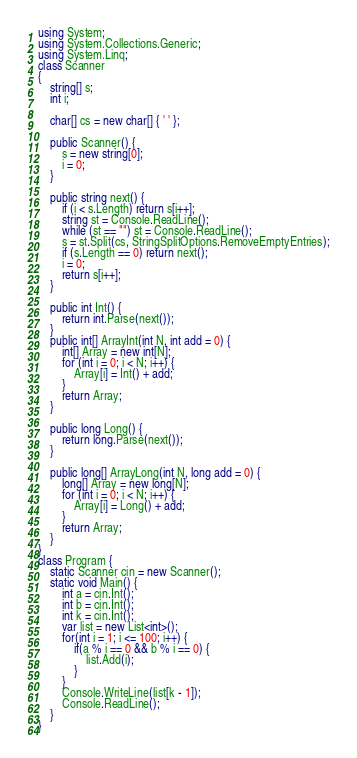<code> <loc_0><loc_0><loc_500><loc_500><_C#_>using System;
using System.Collections.Generic;
using System.Linq;
class Scanner
{
    string[] s;
    int i;

    char[] cs = new char[] { ' ' };

    public Scanner() {
        s = new string[0];
        i = 0;
    }

    public string next() {
        if (i < s.Length) return s[i++];
        string st = Console.ReadLine();
        while (st == "") st = Console.ReadLine();
        s = st.Split(cs, StringSplitOptions.RemoveEmptyEntries);
        if (s.Length == 0) return next();
        i = 0;
        return s[i++];
    }

    public int Int() {
        return int.Parse(next());
    }
    public int[] ArrayInt(int N, int add = 0) {
        int[] Array = new int[N];
        for (int i = 0; i < N; i++) {
            Array[i] = Int() + add;
        }
        return Array;
    }

    public long Long() {
        return long.Parse(next());
    }

    public long[] ArrayLong(int N, long add = 0) {
        long[] Array = new long[N];
        for (int i = 0; i < N; i++) {
            Array[i] = Long() + add;
        }
        return Array;
    }
}
class Program {
    static Scanner cin = new Scanner();
    static void Main() {
        int a = cin.Int();
        int b = cin.Int();
        int k = cin.Int();
        var list = new List<int>();
        for(int i = 1; i <= 100; i++) {
            if(a % i == 0 && b % i == 0) {
                list.Add(i);
            }
        }
        Console.WriteLine(list[k - 1]);
        Console.ReadLine();
    }
}</code> 